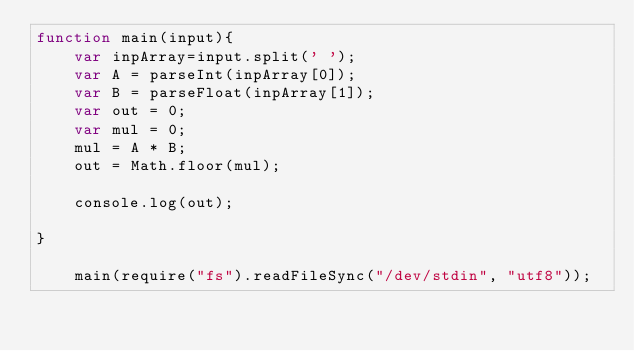Convert code to text. <code><loc_0><loc_0><loc_500><loc_500><_JavaScript_>function main(input){
    var inpArray=input.split(' ');
    var A = parseInt(inpArray[0]);
    var B = parseFloat(inpArray[1]);
    var out = 0;
    var mul = 0;
    mul = A * B;
    out = Math.floor(mul);

    console.log(out);
     
}
     
    main(require("fs").readFileSync("/dev/stdin", "utf8"));</code> 